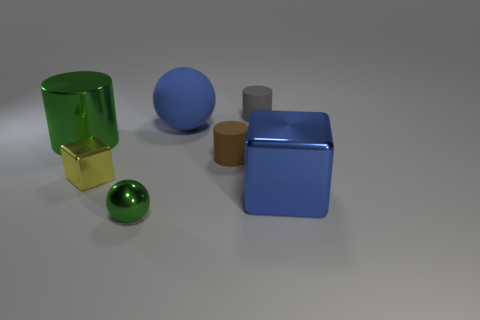Add 1 big green cylinders. How many objects exist? 8 Subtract all cylinders. How many objects are left? 4 Add 6 spheres. How many spheres are left? 8 Add 3 metal spheres. How many metal spheres exist? 4 Subtract 1 gray cylinders. How many objects are left? 6 Subtract all big rubber spheres. Subtract all shiny spheres. How many objects are left? 5 